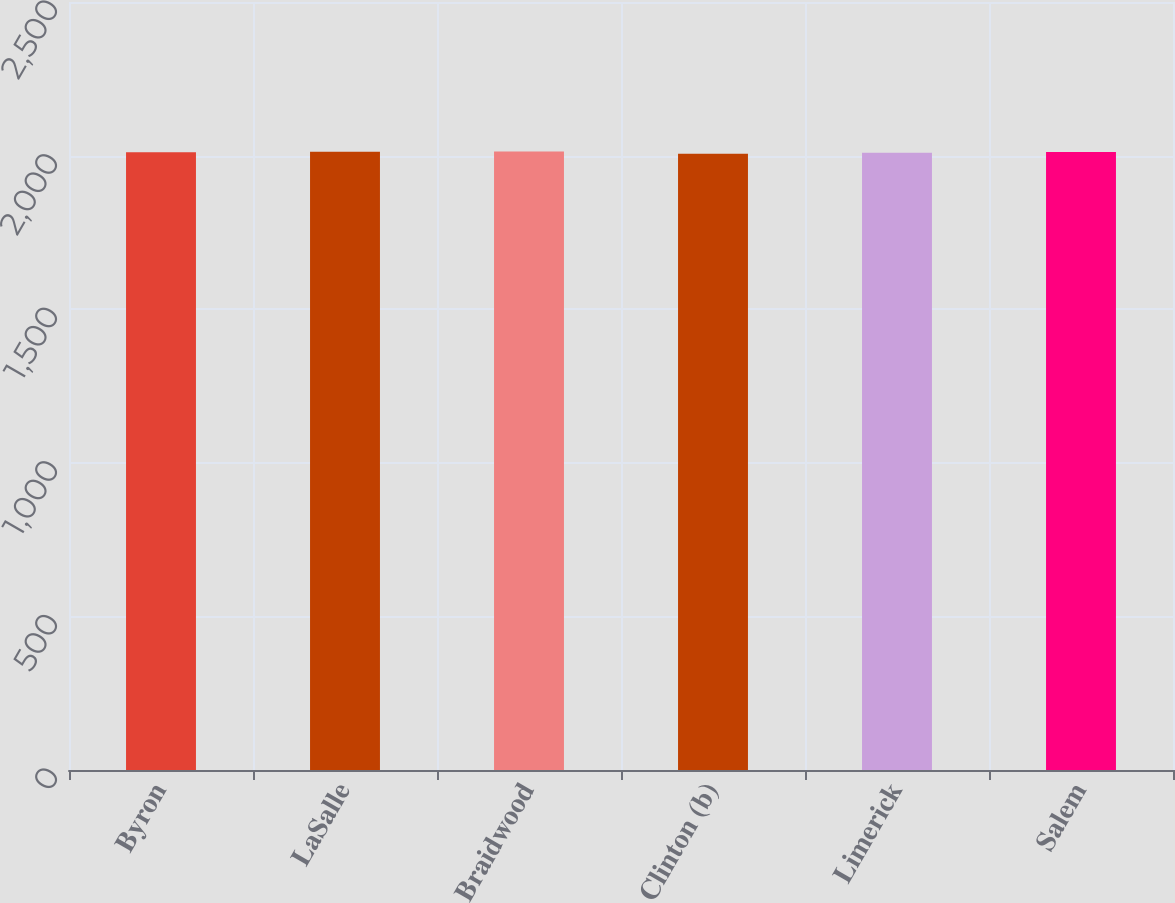<chart> <loc_0><loc_0><loc_500><loc_500><bar_chart><fcel>Byron<fcel>LaSalle<fcel>Braidwood<fcel>Clinton (b)<fcel>Limerick<fcel>Salem<nl><fcel>2011<fcel>2012.4<fcel>2013.1<fcel>2006<fcel>2009<fcel>2011.7<nl></chart> 